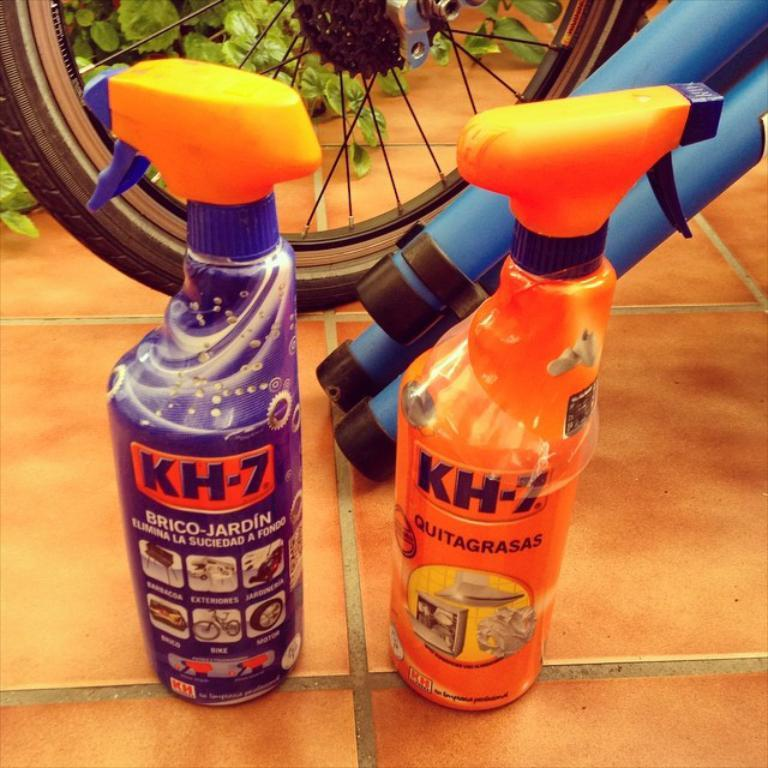How many bottles can be seen in the image? There are two bottles in the image. What else is present on the ground in the image? There is a wheel on the ground in the image. How many men are blowing the wheel in the image? There are no men present in the image, and the wheel is not being blown. 